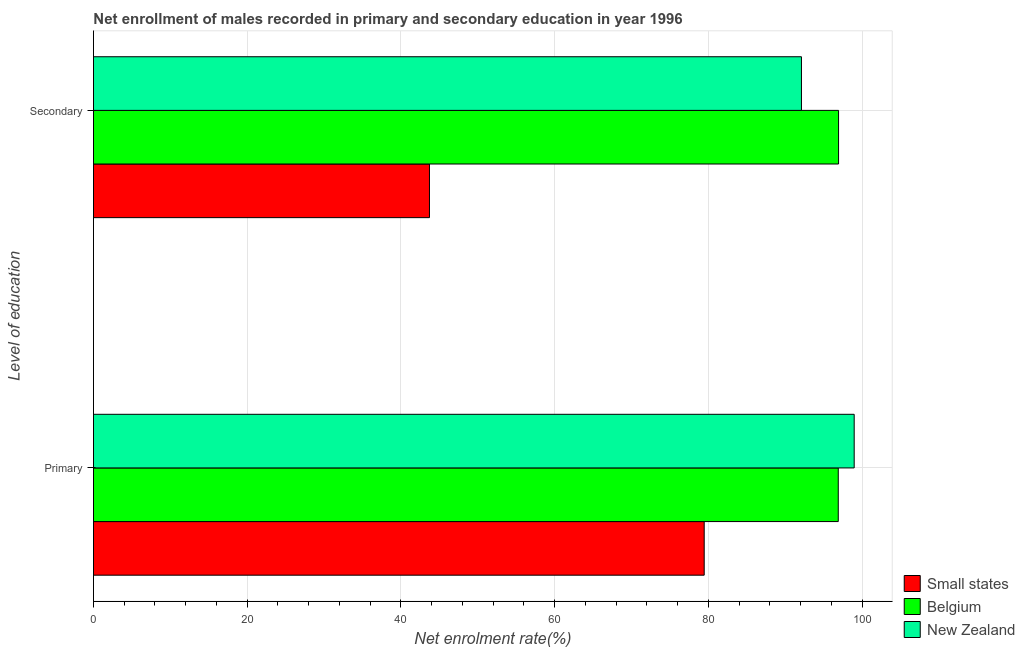How many groups of bars are there?
Keep it short and to the point. 2. How many bars are there on the 1st tick from the bottom?
Your answer should be compact. 3. What is the label of the 1st group of bars from the top?
Your response must be concise. Secondary. What is the enrollment rate in secondary education in Small states?
Make the answer very short. 43.71. Across all countries, what is the maximum enrollment rate in primary education?
Keep it short and to the point. 98.96. Across all countries, what is the minimum enrollment rate in primary education?
Ensure brevity in your answer.  79.45. In which country was the enrollment rate in secondary education maximum?
Keep it short and to the point. Belgium. In which country was the enrollment rate in secondary education minimum?
Provide a succinct answer. Small states. What is the total enrollment rate in secondary education in the graph?
Your response must be concise. 232.74. What is the difference between the enrollment rate in secondary education in Small states and that in Belgium?
Give a very brief answer. -53.22. What is the difference between the enrollment rate in secondary education in Small states and the enrollment rate in primary education in New Zealand?
Give a very brief answer. -55.25. What is the average enrollment rate in primary education per country?
Keep it short and to the point. 91.77. What is the difference between the enrollment rate in secondary education and enrollment rate in primary education in New Zealand?
Provide a short and direct response. -6.86. What is the ratio of the enrollment rate in secondary education in Small states to that in Belgium?
Keep it short and to the point. 0.45. Is the enrollment rate in secondary education in New Zealand less than that in Small states?
Your response must be concise. No. In how many countries, is the enrollment rate in primary education greater than the average enrollment rate in primary education taken over all countries?
Ensure brevity in your answer.  2. What does the 3rd bar from the top in Primary represents?
Offer a very short reply. Small states. What does the 1st bar from the bottom in Secondary represents?
Keep it short and to the point. Small states. How many bars are there?
Your response must be concise. 6. Are all the bars in the graph horizontal?
Ensure brevity in your answer.  Yes. Are the values on the major ticks of X-axis written in scientific E-notation?
Make the answer very short. No. Does the graph contain any zero values?
Ensure brevity in your answer.  No. Does the graph contain grids?
Ensure brevity in your answer.  Yes. Where does the legend appear in the graph?
Provide a short and direct response. Bottom right. How many legend labels are there?
Provide a short and direct response. 3. What is the title of the graph?
Make the answer very short. Net enrollment of males recorded in primary and secondary education in year 1996. What is the label or title of the X-axis?
Provide a succinct answer. Net enrolment rate(%). What is the label or title of the Y-axis?
Make the answer very short. Level of education. What is the Net enrolment rate(%) of Small states in Primary?
Provide a succinct answer. 79.45. What is the Net enrolment rate(%) in Belgium in Primary?
Your answer should be very brief. 96.89. What is the Net enrolment rate(%) of New Zealand in Primary?
Provide a short and direct response. 98.96. What is the Net enrolment rate(%) in Small states in Secondary?
Make the answer very short. 43.71. What is the Net enrolment rate(%) of Belgium in Secondary?
Make the answer very short. 96.93. What is the Net enrolment rate(%) in New Zealand in Secondary?
Give a very brief answer. 92.1. Across all Level of education, what is the maximum Net enrolment rate(%) in Small states?
Give a very brief answer. 79.45. Across all Level of education, what is the maximum Net enrolment rate(%) in Belgium?
Ensure brevity in your answer.  96.93. Across all Level of education, what is the maximum Net enrolment rate(%) in New Zealand?
Give a very brief answer. 98.96. Across all Level of education, what is the minimum Net enrolment rate(%) of Small states?
Provide a succinct answer. 43.71. Across all Level of education, what is the minimum Net enrolment rate(%) in Belgium?
Your answer should be compact. 96.89. Across all Level of education, what is the minimum Net enrolment rate(%) in New Zealand?
Provide a succinct answer. 92.1. What is the total Net enrolment rate(%) in Small states in the graph?
Offer a terse response. 123.16. What is the total Net enrolment rate(%) of Belgium in the graph?
Make the answer very short. 193.82. What is the total Net enrolment rate(%) in New Zealand in the graph?
Your response must be concise. 191.06. What is the difference between the Net enrolment rate(%) in Small states in Primary and that in Secondary?
Keep it short and to the point. 35.74. What is the difference between the Net enrolment rate(%) of Belgium in Primary and that in Secondary?
Your answer should be compact. -0.04. What is the difference between the Net enrolment rate(%) of New Zealand in Primary and that in Secondary?
Your response must be concise. 6.86. What is the difference between the Net enrolment rate(%) in Small states in Primary and the Net enrolment rate(%) in Belgium in Secondary?
Give a very brief answer. -17.48. What is the difference between the Net enrolment rate(%) of Small states in Primary and the Net enrolment rate(%) of New Zealand in Secondary?
Keep it short and to the point. -12.65. What is the difference between the Net enrolment rate(%) of Belgium in Primary and the Net enrolment rate(%) of New Zealand in Secondary?
Provide a succinct answer. 4.79. What is the average Net enrolment rate(%) in Small states per Level of education?
Your answer should be very brief. 61.58. What is the average Net enrolment rate(%) of Belgium per Level of education?
Keep it short and to the point. 96.91. What is the average Net enrolment rate(%) of New Zealand per Level of education?
Your answer should be compact. 95.53. What is the difference between the Net enrolment rate(%) in Small states and Net enrolment rate(%) in Belgium in Primary?
Offer a very short reply. -17.44. What is the difference between the Net enrolment rate(%) in Small states and Net enrolment rate(%) in New Zealand in Primary?
Your answer should be very brief. -19.51. What is the difference between the Net enrolment rate(%) of Belgium and Net enrolment rate(%) of New Zealand in Primary?
Provide a succinct answer. -2.07. What is the difference between the Net enrolment rate(%) of Small states and Net enrolment rate(%) of Belgium in Secondary?
Provide a succinct answer. -53.22. What is the difference between the Net enrolment rate(%) of Small states and Net enrolment rate(%) of New Zealand in Secondary?
Give a very brief answer. -48.39. What is the difference between the Net enrolment rate(%) of Belgium and Net enrolment rate(%) of New Zealand in Secondary?
Your response must be concise. 4.83. What is the ratio of the Net enrolment rate(%) of Small states in Primary to that in Secondary?
Your answer should be compact. 1.82. What is the ratio of the Net enrolment rate(%) in Belgium in Primary to that in Secondary?
Offer a very short reply. 1. What is the ratio of the Net enrolment rate(%) in New Zealand in Primary to that in Secondary?
Provide a short and direct response. 1.07. What is the difference between the highest and the second highest Net enrolment rate(%) of Small states?
Your answer should be compact. 35.74. What is the difference between the highest and the second highest Net enrolment rate(%) in Belgium?
Your response must be concise. 0.04. What is the difference between the highest and the second highest Net enrolment rate(%) of New Zealand?
Your answer should be very brief. 6.86. What is the difference between the highest and the lowest Net enrolment rate(%) in Small states?
Offer a terse response. 35.74. What is the difference between the highest and the lowest Net enrolment rate(%) in Belgium?
Offer a very short reply. 0.04. What is the difference between the highest and the lowest Net enrolment rate(%) in New Zealand?
Provide a succinct answer. 6.86. 